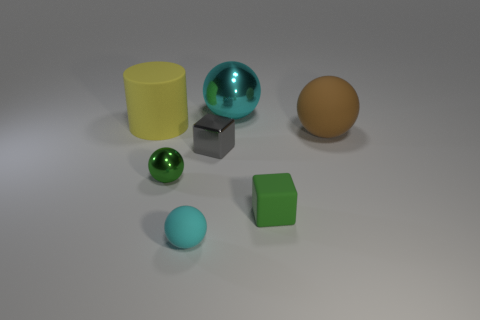What size is the shiny object that is the same color as the rubber block?
Your answer should be compact. Small. Does the small green thing that is behind the matte block have the same material as the tiny green cube?
Ensure brevity in your answer.  No. Is there a green block that is in front of the small matte object that is in front of the small cube that is in front of the small green sphere?
Your response must be concise. No. There is a cyan thing that is in front of the large yellow matte thing; is it the same shape as the small green metallic object?
Provide a succinct answer. Yes. What is the shape of the metallic object that is on the left side of the cyan thing that is in front of the brown rubber sphere?
Ensure brevity in your answer.  Sphere. There is a metal sphere that is behind the large ball right of the tiny rubber object on the right side of the gray metal cube; what size is it?
Your answer should be very brief. Large. The other tiny thing that is the same shape as the green matte object is what color?
Provide a short and direct response. Gray. Do the yellow cylinder and the cyan metallic sphere have the same size?
Keep it short and to the point. Yes. There is a cyan sphere that is behind the brown ball; what is it made of?
Offer a terse response. Metal. What number of other things are there of the same shape as the big yellow object?
Ensure brevity in your answer.  0. 